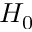<formula> <loc_0><loc_0><loc_500><loc_500>H _ { 0 }</formula> 